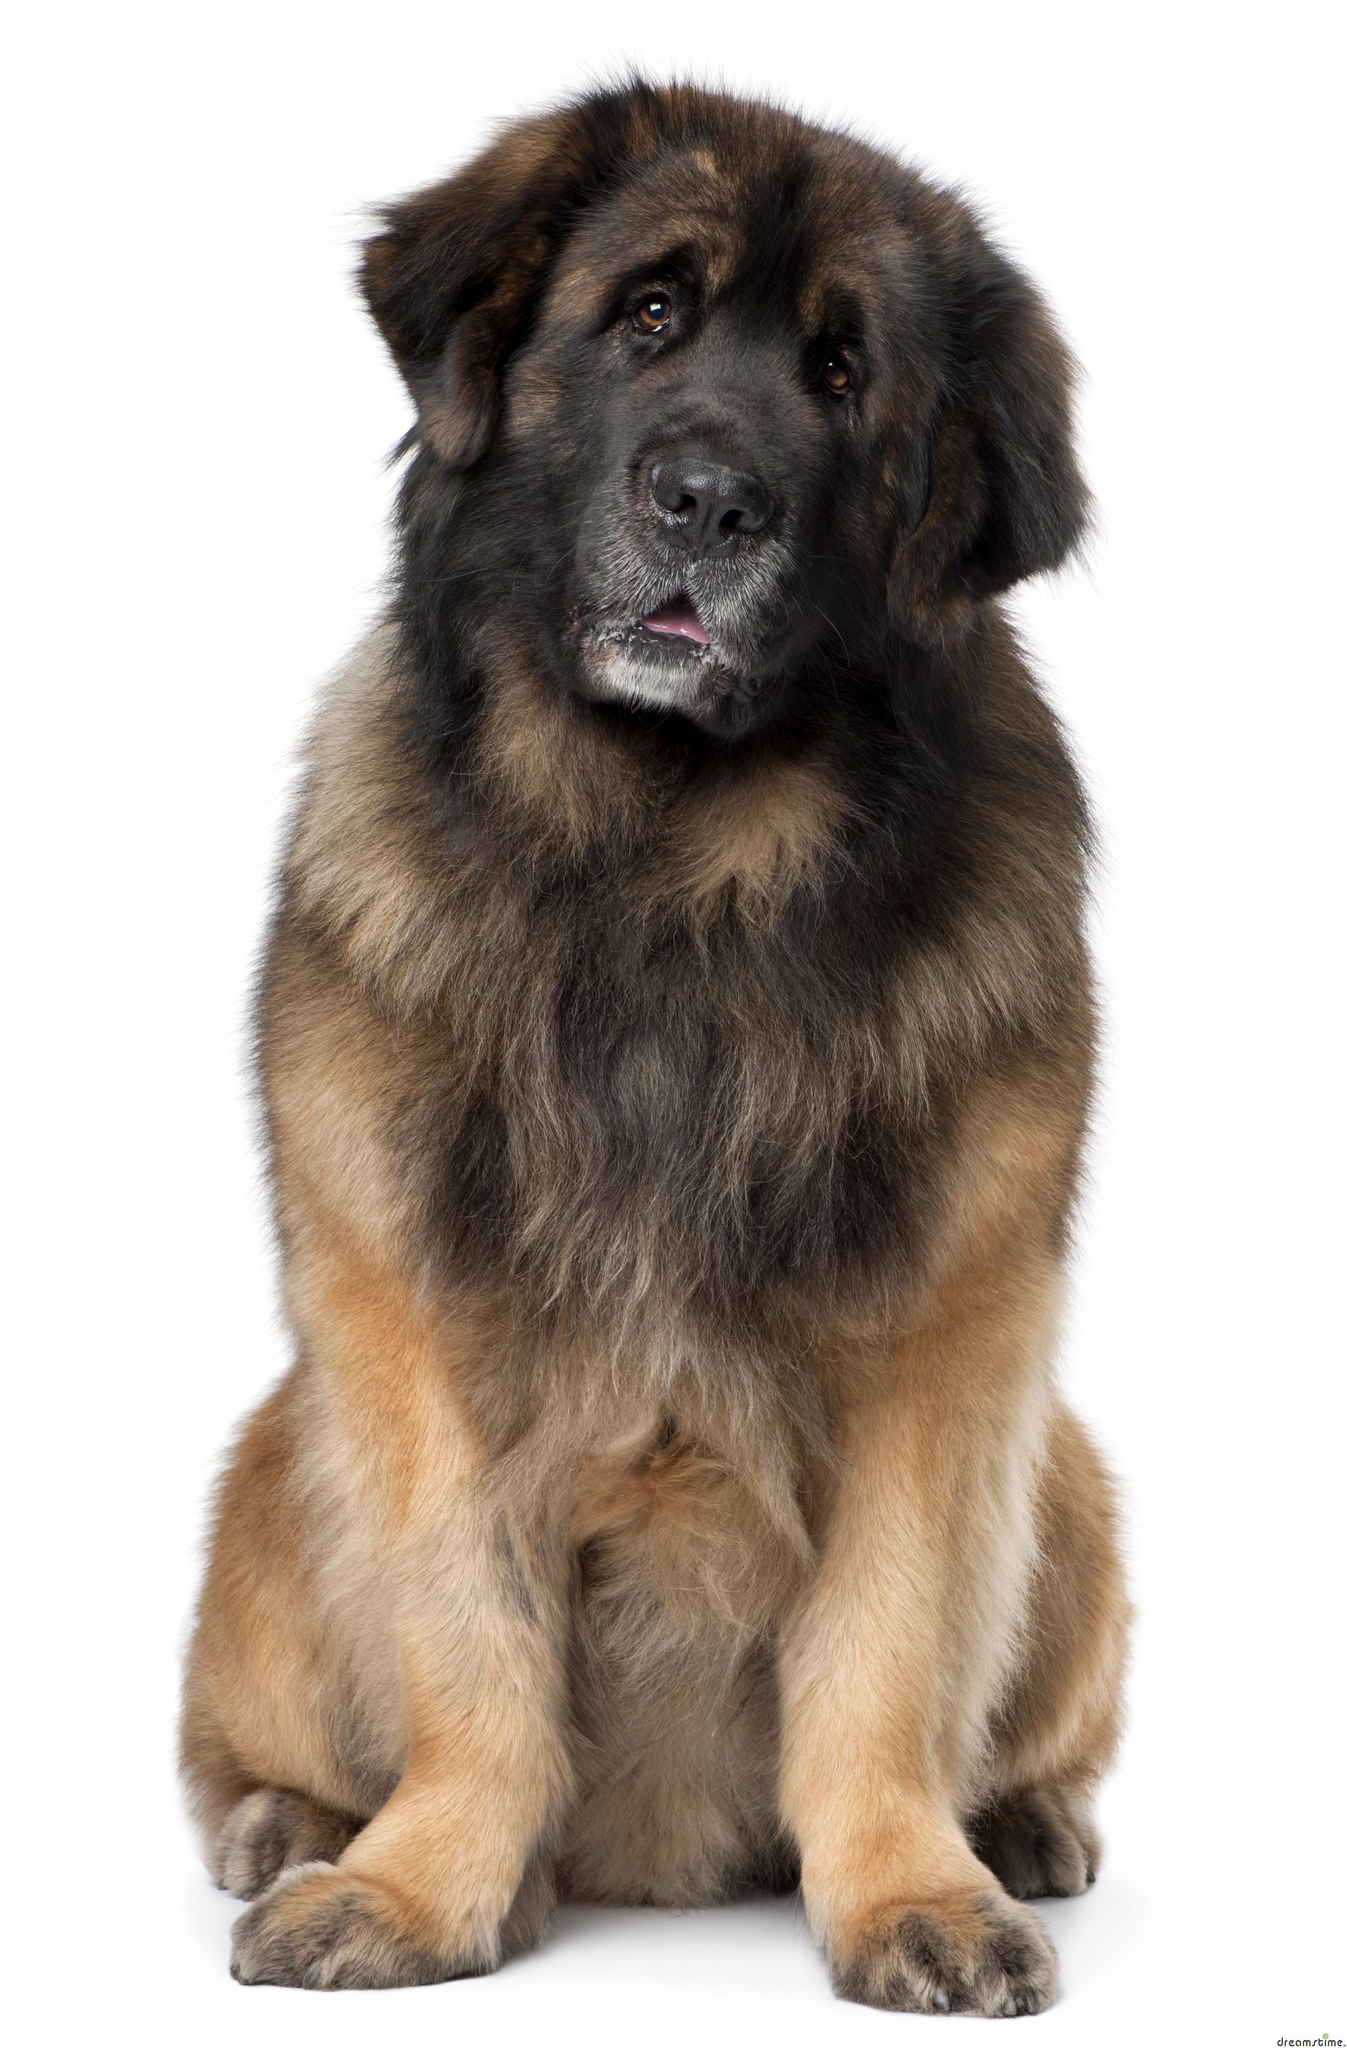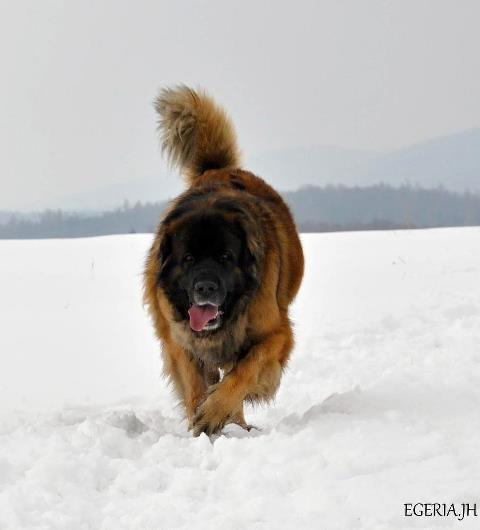The first image is the image on the left, the second image is the image on the right. For the images shown, is this caption "A dog is on a ground filled with snow." true? Answer yes or no. Yes. The first image is the image on the left, the second image is the image on the right. Considering the images on both sides, is "One image shows a dog on snow-covered ground." valid? Answer yes or no. Yes. 